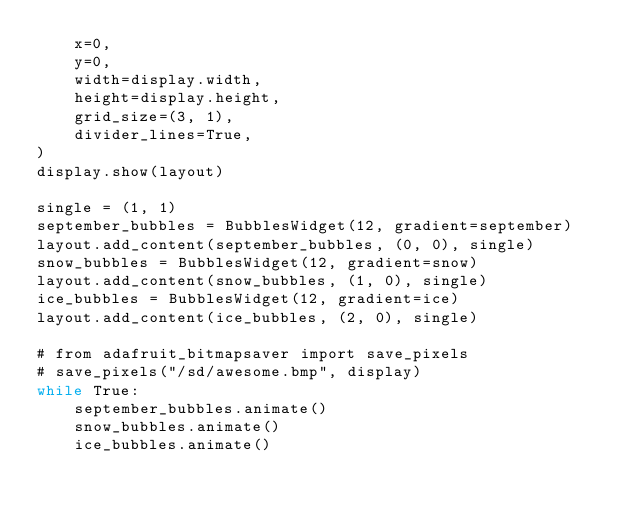Convert code to text. <code><loc_0><loc_0><loc_500><loc_500><_Python_>    x=0,
    y=0,
    width=display.width,
    height=display.height,
    grid_size=(3, 1),
    divider_lines=True,
)
display.show(layout)

single = (1, 1)
september_bubbles = BubblesWidget(12, gradient=september)
layout.add_content(september_bubbles, (0, 0), single)
snow_bubbles = BubblesWidget(12, gradient=snow)
layout.add_content(snow_bubbles, (1, 0), single)
ice_bubbles = BubblesWidget(12, gradient=ice)
layout.add_content(ice_bubbles, (2, 0), single)

# from adafruit_bitmapsaver import save_pixels
# save_pixels("/sd/awesome.bmp", display)
while True:
    september_bubbles.animate()
    snow_bubbles.animate()
    ice_bubbles.animate()
</code> 